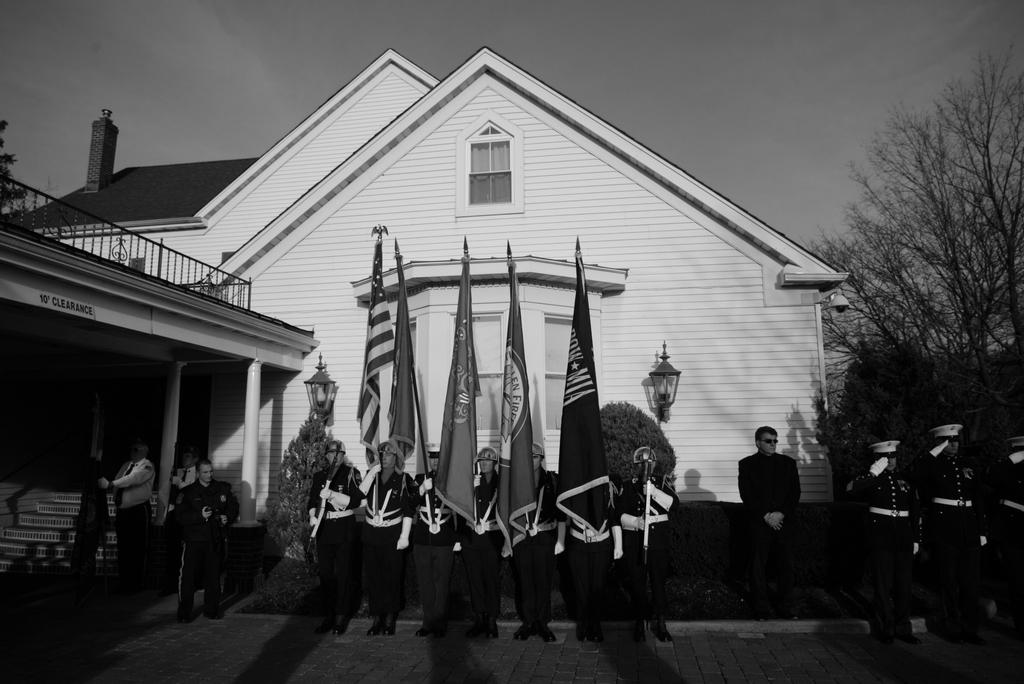What are the people in the image doing? The people in the image are standing and holding flags. What can be seen in the background of the image? There is a house, plants, trees, lights, and the sky visible in the background of the image. What type of wood is being used to build the cannon in the image? There is no cannon present in the image, so it is not possible to determine the type of wood being used. What discovery was made by the people holding flags in the image? There is no indication of a discovery being made in the image; the people are simply holding flags. 